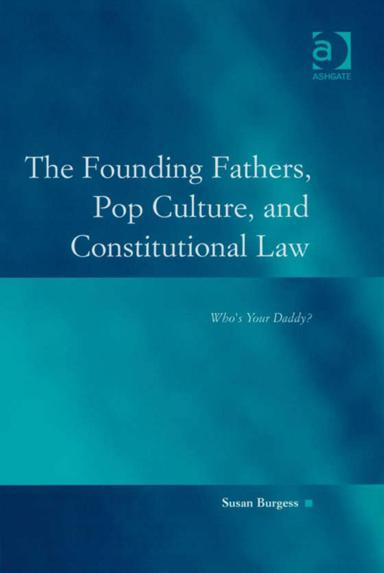What might be the significance of the book's subtitle, 'Who's Your Daddy?' in the context of constitutional law? The subtitle 'Who's Your Daddy?' is a provocative inquiry into paternalistic themes in constitutional law, possibly challenging or reflecting on the authoritative figures and founding principles that govern and shape U.S. jurisprudence. 